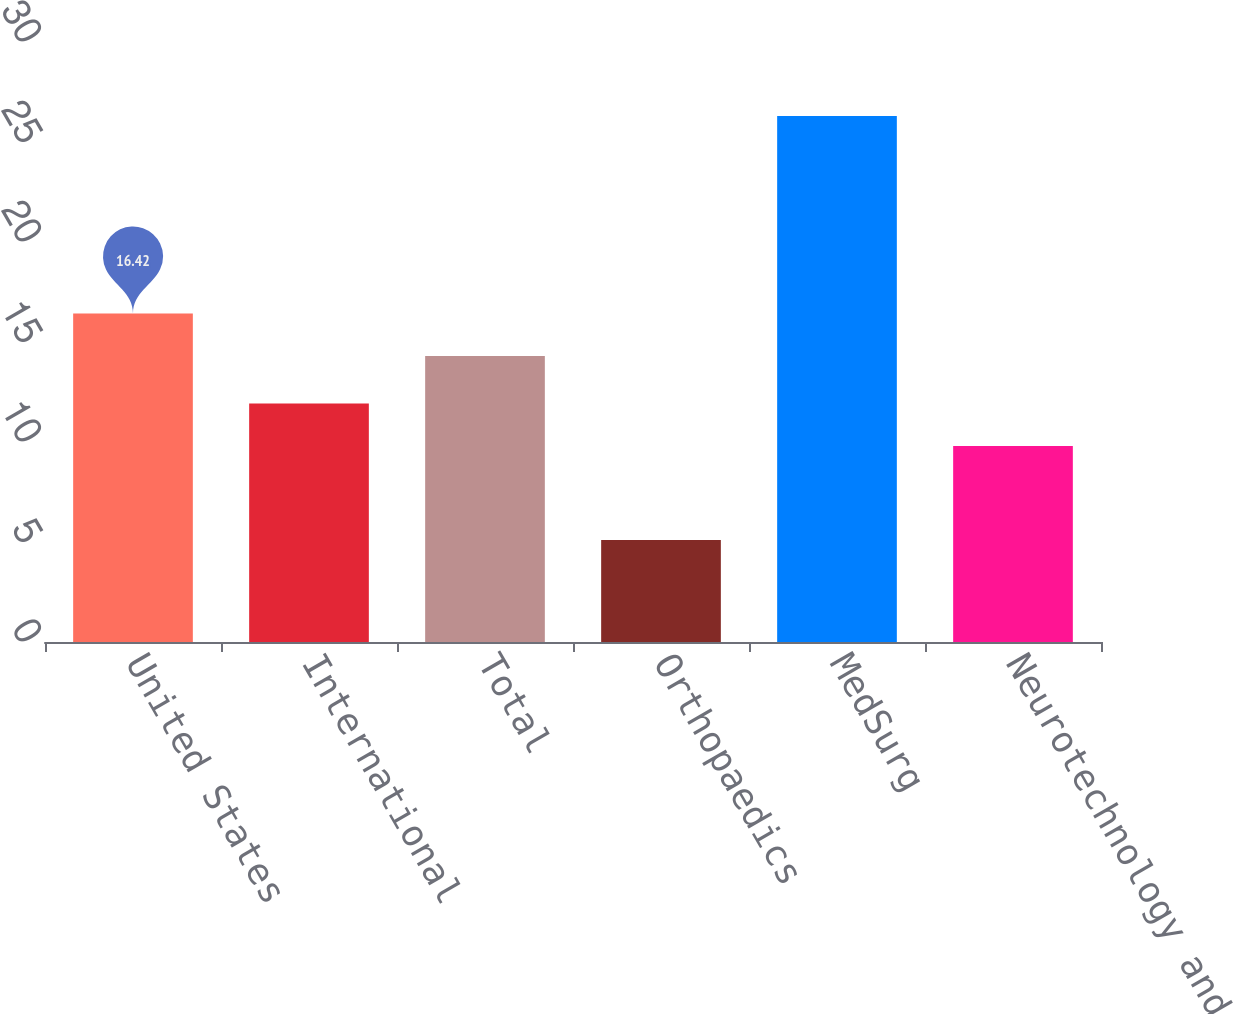Convert chart to OTSL. <chart><loc_0><loc_0><loc_500><loc_500><bar_chart><fcel>United States<fcel>International<fcel>Total<fcel>Orthopaedics<fcel>MedSurg<fcel>Neurotechnology and Spine<nl><fcel>16.42<fcel>11.92<fcel>14.3<fcel>5.1<fcel>26.3<fcel>9.8<nl></chart> 